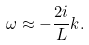Convert formula to latex. <formula><loc_0><loc_0><loc_500><loc_500>\omega \approx - \frac { 2 i } { L } k .</formula> 